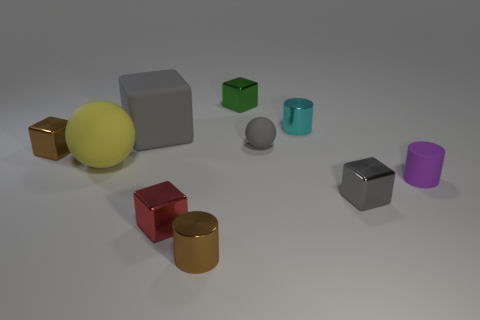Subtract all small blocks. How many blocks are left? 1 Subtract all yellow cylinders. How many gray blocks are left? 2 Subtract all green blocks. How many blocks are left? 4 Subtract all cyan cubes. Subtract all green balls. How many cubes are left? 5 Subtract all spheres. How many objects are left? 8 Subtract all tiny brown metal cylinders. Subtract all shiny cylinders. How many objects are left? 7 Add 3 green metallic things. How many green metallic things are left? 4 Add 4 metal cylinders. How many metal cylinders exist? 6 Subtract 0 blue cylinders. How many objects are left? 10 